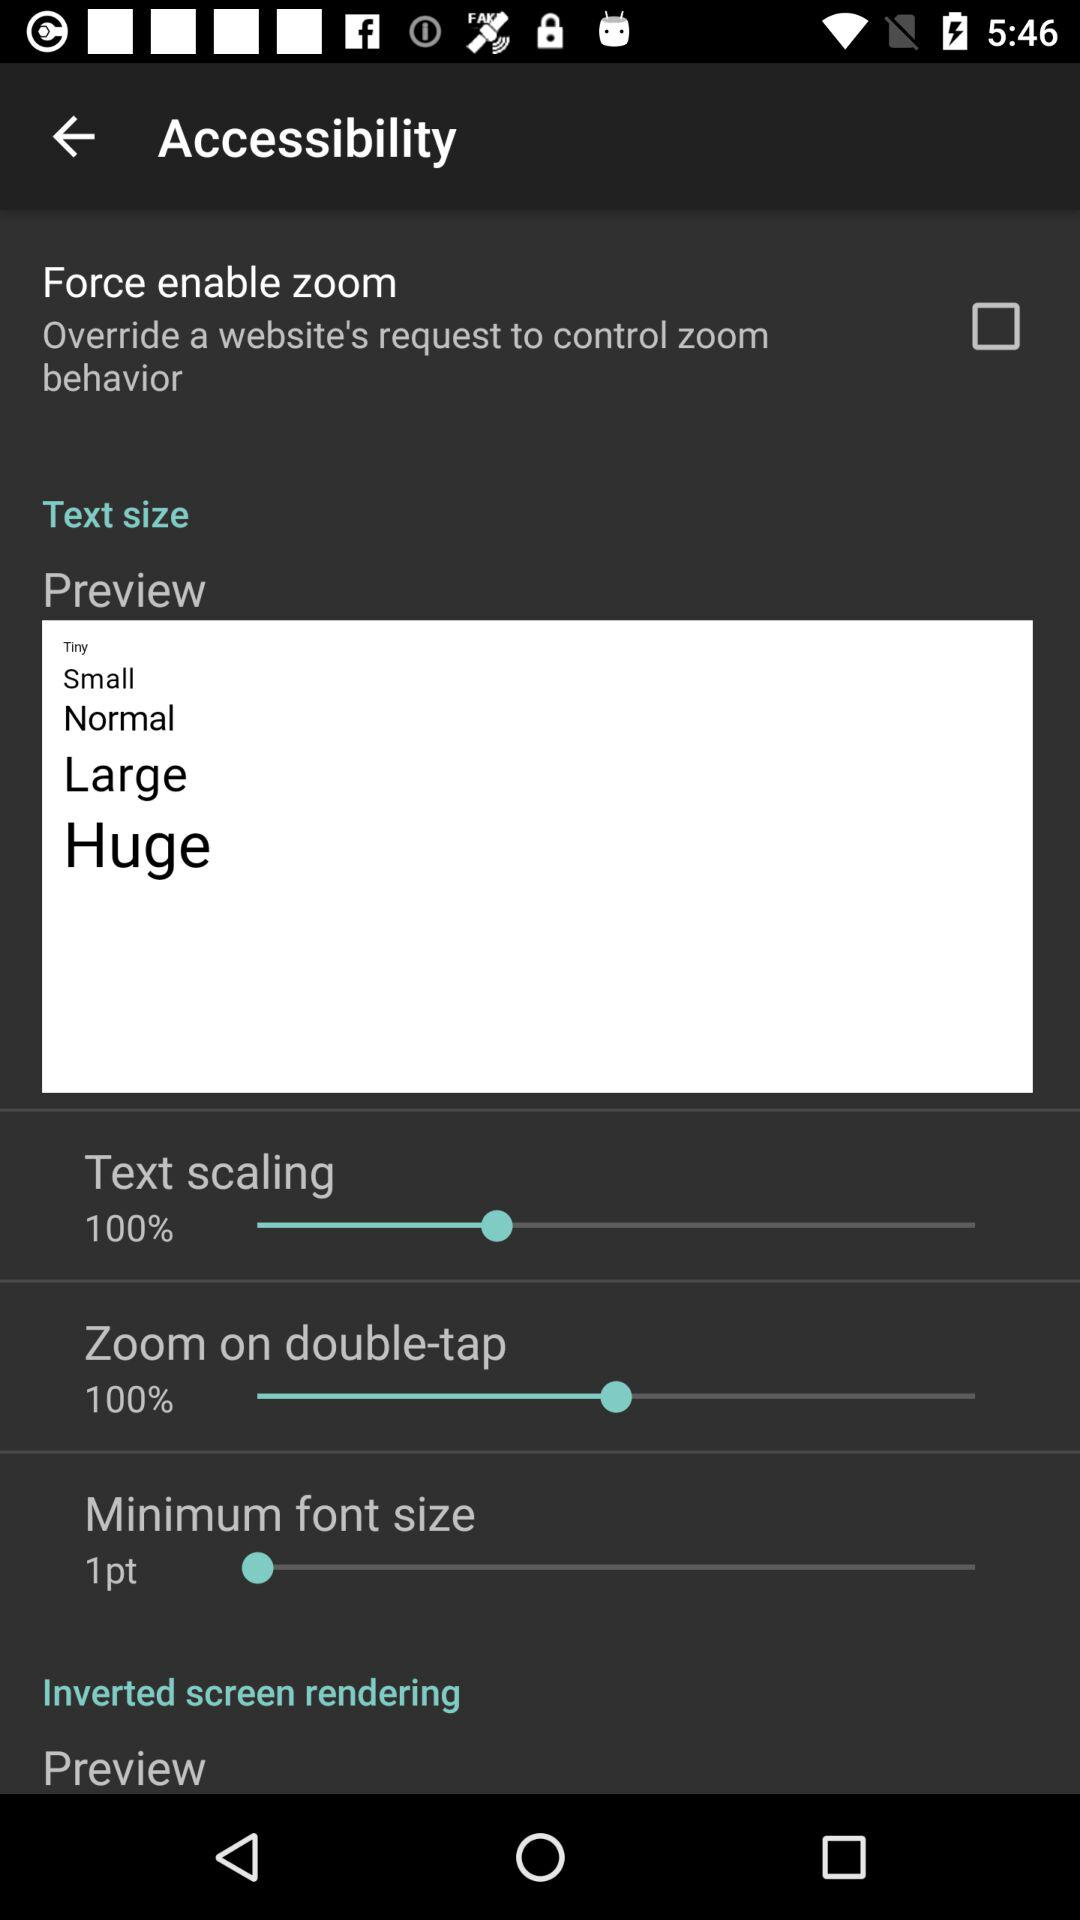What is the percentage of zoom on double-tap? The percentage of zoom on double-tap is 100. 